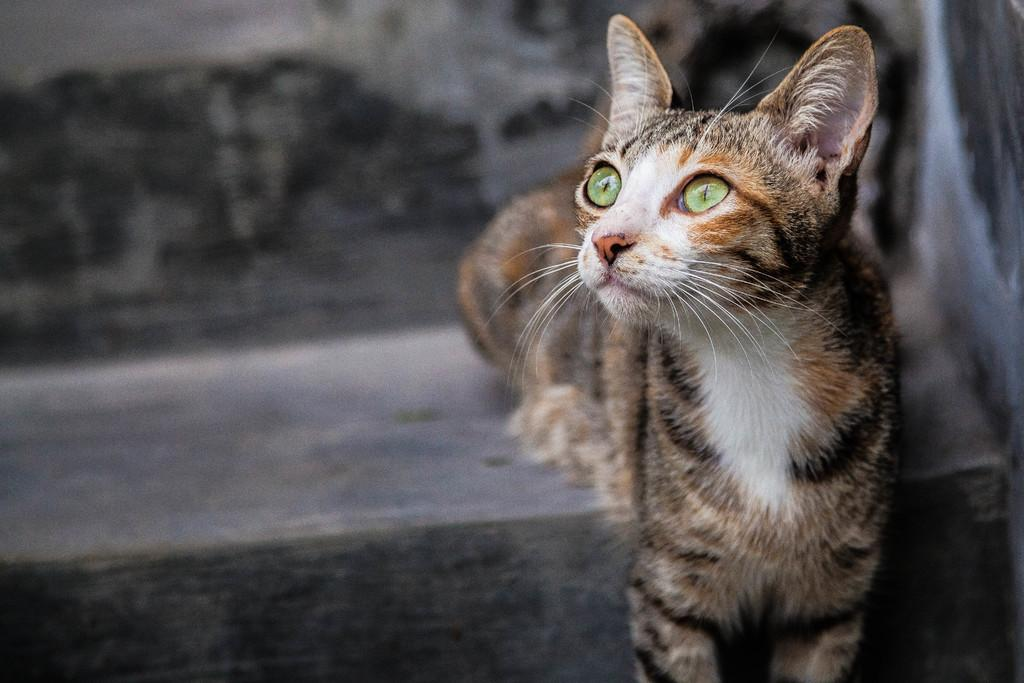What type of animal is in the image? There is a cat in the image. What colors can be seen on the cat? The cat has white, brown, and black colors. Can you describe the background of the image? The background of the image is blurred. What type of chain is the cat holding in the image? There is no chain present in the image; the cat is not holding anything. 